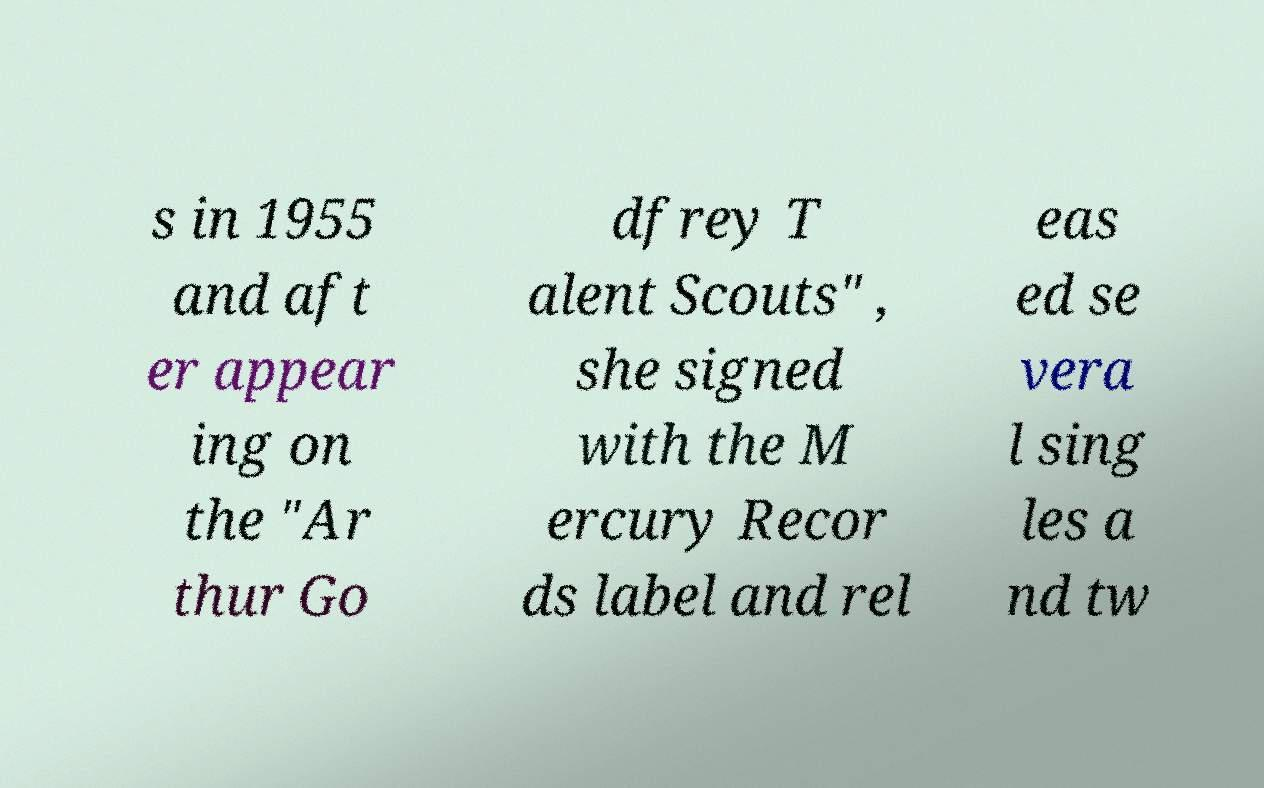Please identify and transcribe the text found in this image. s in 1955 and aft er appear ing on the "Ar thur Go dfrey T alent Scouts" , she signed with the M ercury Recor ds label and rel eas ed se vera l sing les a nd tw 